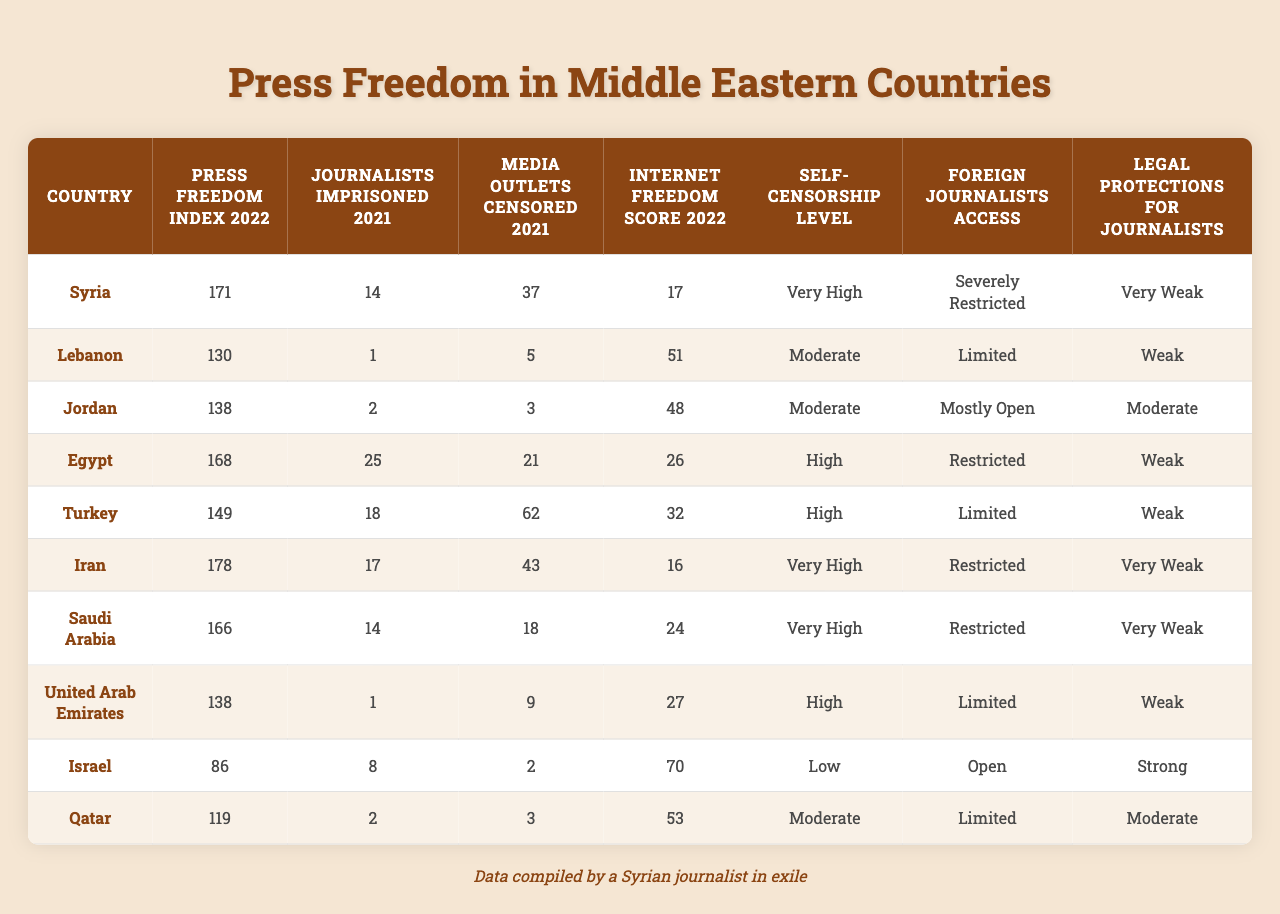What is the press freedom index for Israel? The press freedom index for Israel is represented as the value in the corresponding row for Israel in the "Press Freedom Index 2022" column, which is 86.
Answer: 86 Which country has the highest number of journalists imprisoned in 2021? By reviewing the "Journalists Imprisoned 2021" column, Egypt has the highest number of journalists imprisoned, totaling 25.
Answer: Egypt How many media outlets were censored in Syria in 2021? From the "Media Outlets Censored 2021" column, Syria has 37 media outlets censored in that year.
Answer: 37 What is the internet freedom score for Jordan? The internet freedom score for Jordan is found by checking the "Internet Freedom Score 2022" column, which is 48.
Answer: 48 Is the self-censorship level in Iran classified as high? Referring to the "Self-Censorship Level" column, Iran's self-censorship level is classified as "Very High." So the statement is false.
Answer: No Which country has the lowest press freedom index and what is the value? Syria has the lowest press freedom index at 171 when looking at the values in the "Press Freedom Index 2022" column.
Answer: Syria, 171 Compare the journalists imprisoned between Saudi Arabia and Turkey. In the "Journalists Imprisoned 2021" column, Saudi Arabia has 14 imprisoned journalists while Turkey has 18. Therefore, Turkey has more imprisoned journalists than Saudi Arabia.
Answer: Turkey has 18, Saudi Arabia has 14 What is the total number of journalists imprisoned across all listed countries? To find the total, add up all values from the "Journalists Imprisoned 2021" column: 14 + 1 + 2 + 25 + 18 + 17 + 14 + 1 + 8 + 2 = 102.
Answer: 102 How many countries have a "Very Weak" rating for legal protections for journalists? Looking in the "Legal Protections for Journalists" column, Syria, Iran, Saudi Arabia, and the UAE each have "Very Weak" ratings. This totals to 4 countries.
Answer: 4 What is the average number of media outlets censored across the Middle Eastern countries listed? First, add all the values in the "Media Outlets Censored 2021" column, which sums to 37 + 5 + 3 + 21 + 62 + 43 + 18 + 9 + 2 + 3 = 203. There are 10 countries, so the average is 203/10 = 20.3.
Answer: 20.3 Has any country achieved an "Open" status for foreign journalists' access? By checking the "Foreign Journalists Access" column, Israel has "Open" status for foreign journalists, confirming the statement is true.
Answer: Yes 